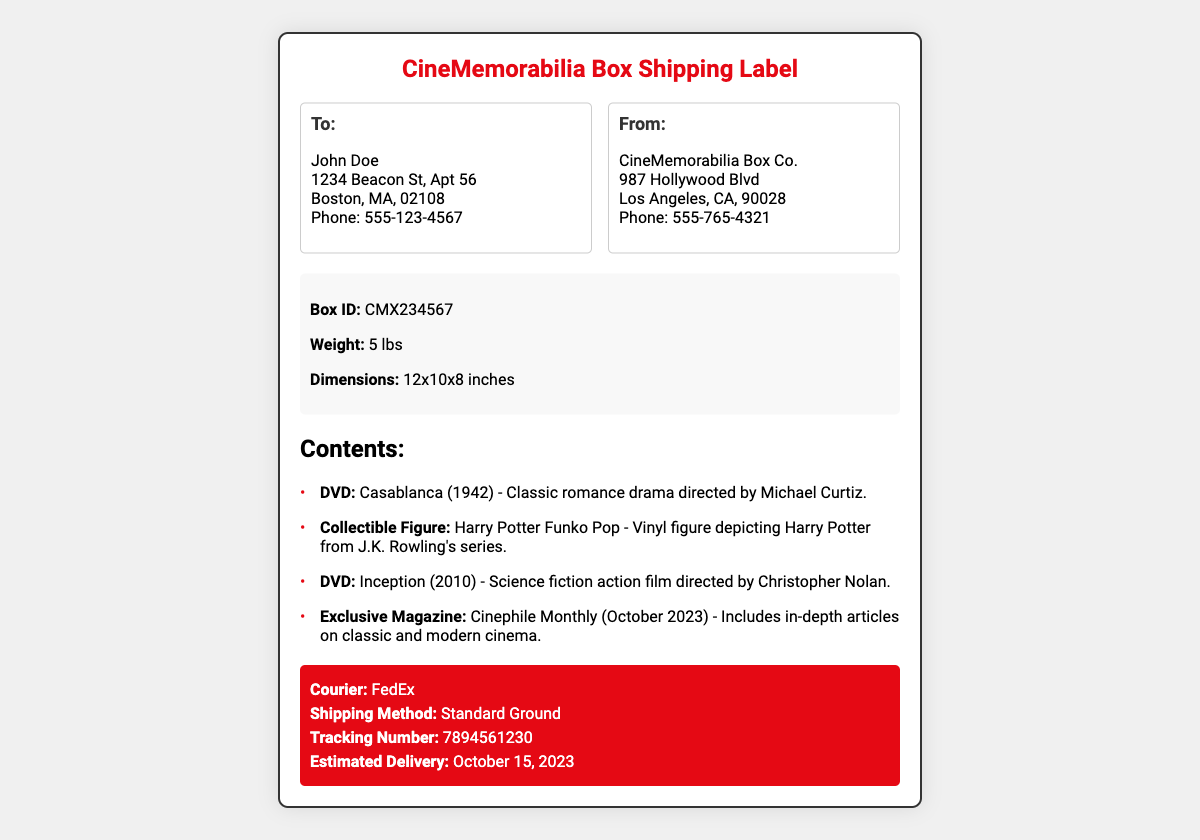What is the name of the recipient? The document lists the recipient's name at the beginning of the address section.
Answer: John Doe What is the address of the sender? The sender's address is provided in the 'From' section of the document.
Answer: 987 Hollywood Blvd, Los Angeles, CA, 90028 What are the dimensions of the box? The dimensions of the box are specified in the box details section.
Answer: 12x10x8 inches What is the tracking number? The tracking number is listed in the shipping information section.
Answer: 7894561230 How many movies are included in the box? The document mentions two DVDs in the contents section.
Answer: 2 What is the estimated delivery date? The estimated delivery date is found in the shipping information section.
Answer: October 15, 2023 What is the weight of the box? The weight of the box is provided in the box details.
Answer: 5 lbs What type of figure is included? The contents section specifies the type of figure.
Answer: Funko Pop What is the name of the magazine? The exclusive magazine is listed in the contents section.
Answer: Cinephile Monthly 